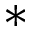Convert formula to latex. <formula><loc_0><loc_0><loc_500><loc_500>\ast</formula> 